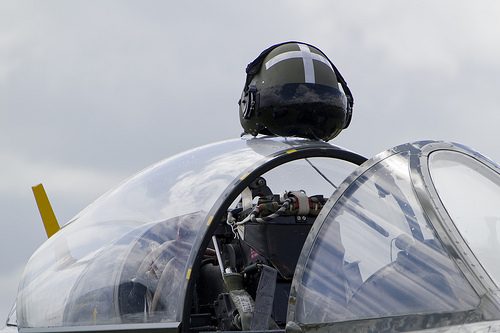<image>
Can you confirm if the case box is in the jet plane? Yes. The case box is contained within or inside the jet plane, showing a containment relationship. 